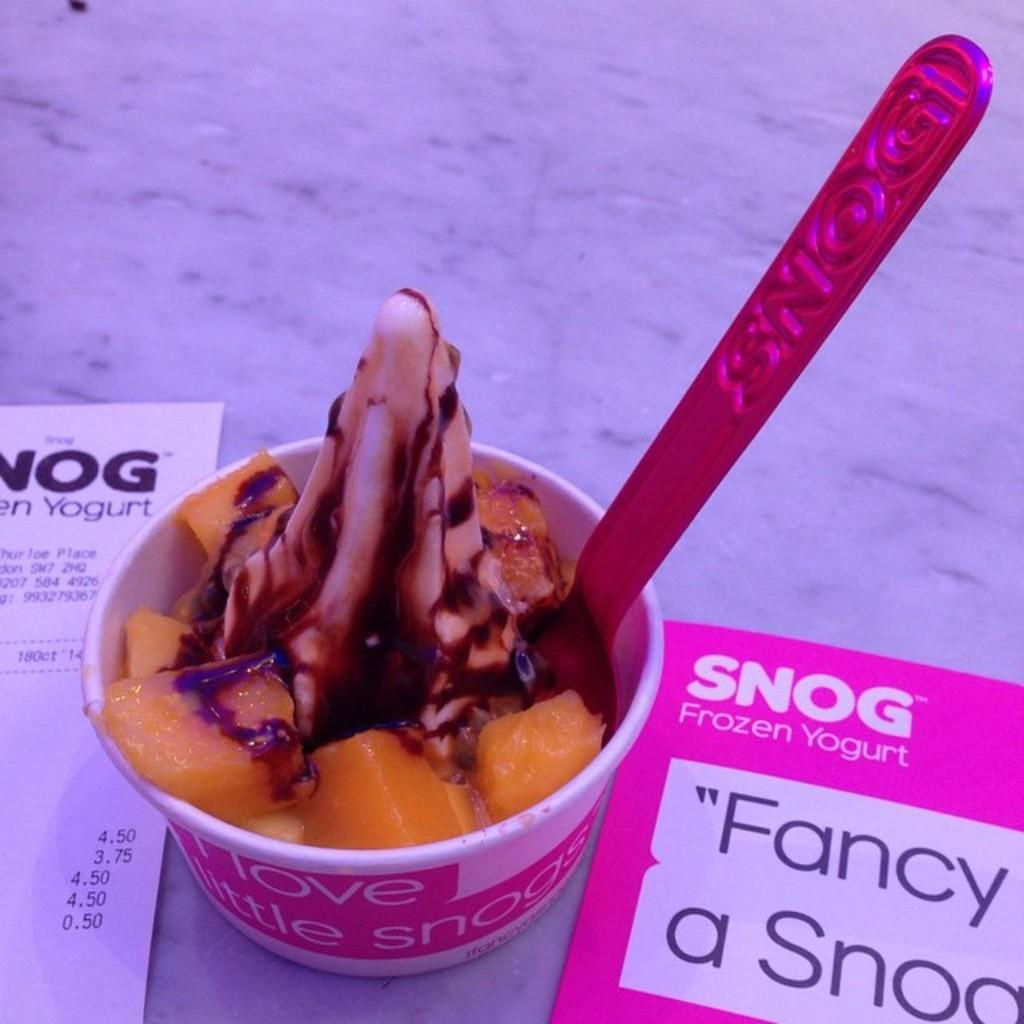What is the main piece of furniture in the image? There is a table in the image. What is placed on the table? There is an ice cream cup on the table. What is inside the ice cream cup? The ice cream cup has a spoon in it. What other item can be seen in the image? There is a rate card present in the image. How many chairs are visible in the image? There are no chairs visible in the image. What type of yarn is being used to create the ice cream cup? The ice cream cup is not made of yarn; it is a container for ice cream. 